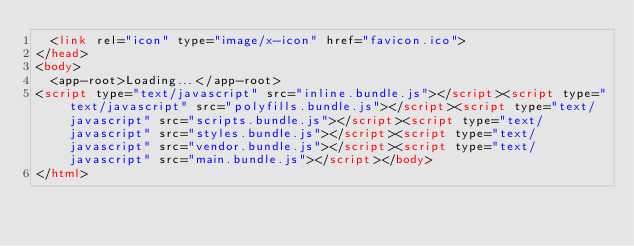Convert code to text. <code><loc_0><loc_0><loc_500><loc_500><_HTML_>  <link rel="icon" type="image/x-icon" href="favicon.ico">
</head>
<body>
  <app-root>Loading...</app-root>
<script type="text/javascript" src="inline.bundle.js"></script><script type="text/javascript" src="polyfills.bundle.js"></script><script type="text/javascript" src="scripts.bundle.js"></script><script type="text/javascript" src="styles.bundle.js"></script><script type="text/javascript" src="vendor.bundle.js"></script><script type="text/javascript" src="main.bundle.js"></script></body>
</html>
</code> 